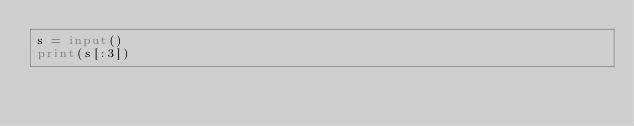Convert code to text. <code><loc_0><loc_0><loc_500><loc_500><_Python_>s = input()
print(s[:3])
</code> 